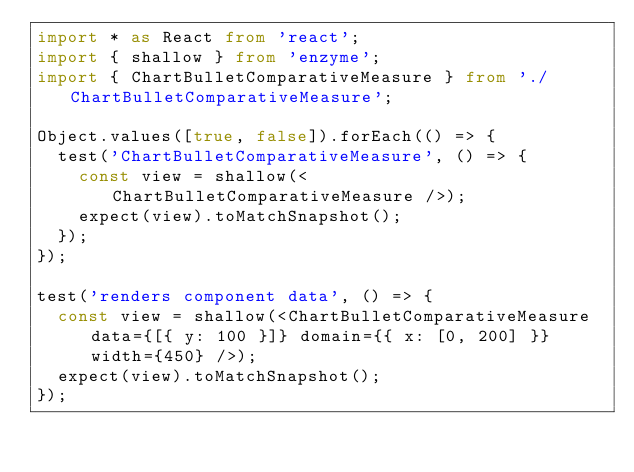Convert code to text. <code><loc_0><loc_0><loc_500><loc_500><_TypeScript_>import * as React from 'react';
import { shallow } from 'enzyme';
import { ChartBulletComparativeMeasure } from './ChartBulletComparativeMeasure';

Object.values([true, false]).forEach(() => {
  test('ChartBulletComparativeMeasure', () => {
    const view = shallow(<ChartBulletComparativeMeasure />);
    expect(view).toMatchSnapshot();
  });
});

test('renders component data', () => {
  const view = shallow(<ChartBulletComparativeMeasure data={[{ y: 100 }]} domain={{ x: [0, 200] }} width={450} />);
  expect(view).toMatchSnapshot();
});
</code> 